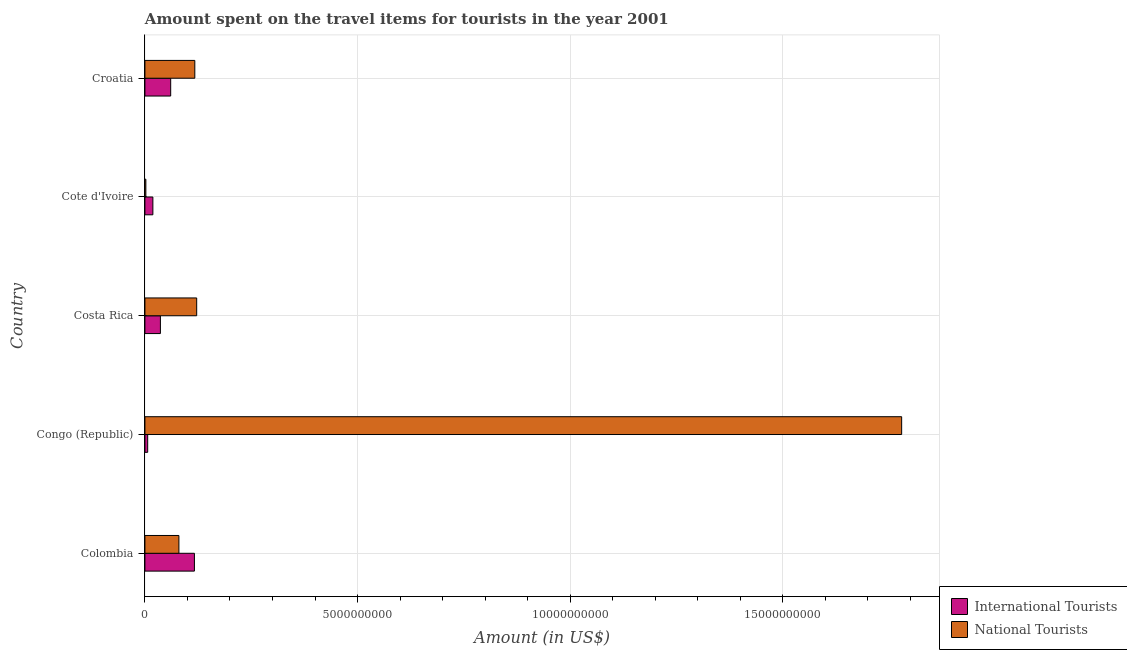How many different coloured bars are there?
Make the answer very short. 2. Are the number of bars per tick equal to the number of legend labels?
Keep it short and to the point. Yes. Are the number of bars on each tick of the Y-axis equal?
Your response must be concise. Yes. How many bars are there on the 1st tick from the top?
Offer a terse response. 2. What is the label of the 1st group of bars from the top?
Your answer should be compact. Croatia. What is the amount spent on travel items of international tourists in Costa Rica?
Your answer should be very brief. 3.64e+08. Across all countries, what is the maximum amount spent on travel items of national tourists?
Your answer should be compact. 1.78e+1. Across all countries, what is the minimum amount spent on travel items of international tourists?
Provide a short and direct response. 6.50e+07. In which country was the amount spent on travel items of international tourists maximum?
Make the answer very short. Colombia. In which country was the amount spent on travel items of national tourists minimum?
Offer a terse response. Cote d'Ivoire. What is the total amount spent on travel items of international tourists in the graph?
Provide a short and direct response. 2.39e+09. What is the difference between the amount spent on travel items of national tourists in Congo (Republic) and that in Croatia?
Your response must be concise. 1.66e+1. What is the difference between the amount spent on travel items of national tourists in Costa Rica and the amount spent on travel items of international tourists in Cote d'Ivoire?
Your answer should be very brief. 1.03e+09. What is the average amount spent on travel items of national tourists per country?
Your answer should be very brief. 4.20e+09. What is the difference between the amount spent on travel items of international tourists and amount spent on travel items of national tourists in Congo (Republic)?
Offer a very short reply. -1.77e+1. What is the ratio of the amount spent on travel items of international tourists in Colombia to that in Costa Rica?
Ensure brevity in your answer.  3.2. Is the amount spent on travel items of international tourists in Congo (Republic) less than that in Croatia?
Offer a very short reply. Yes. Is the difference between the amount spent on travel items of national tourists in Colombia and Croatia greater than the difference between the amount spent on travel items of international tourists in Colombia and Croatia?
Offer a very short reply. No. What is the difference between the highest and the second highest amount spent on travel items of international tourists?
Give a very brief answer. 5.58e+08. What is the difference between the highest and the lowest amount spent on travel items of international tourists?
Give a very brief answer. 1.10e+09. What does the 2nd bar from the top in Cote d'Ivoire represents?
Your answer should be very brief. International Tourists. What does the 1st bar from the bottom in Cote d'Ivoire represents?
Ensure brevity in your answer.  International Tourists. How many countries are there in the graph?
Make the answer very short. 5. Does the graph contain any zero values?
Your answer should be very brief. No. Where does the legend appear in the graph?
Keep it short and to the point. Bottom right. How many legend labels are there?
Provide a succinct answer. 2. What is the title of the graph?
Offer a terse response. Amount spent on the travel items for tourists in the year 2001. Does "Under-5(female)" appear as one of the legend labels in the graph?
Provide a succinct answer. No. What is the label or title of the Y-axis?
Give a very brief answer. Country. What is the Amount (in US$) of International Tourists in Colombia?
Your response must be concise. 1.16e+09. What is the Amount (in US$) in National Tourists in Colombia?
Your answer should be compact. 7.99e+08. What is the Amount (in US$) in International Tourists in Congo (Republic)?
Ensure brevity in your answer.  6.50e+07. What is the Amount (in US$) in National Tourists in Congo (Republic)?
Offer a very short reply. 1.78e+1. What is the Amount (in US$) of International Tourists in Costa Rica?
Your answer should be very brief. 3.64e+08. What is the Amount (in US$) in National Tourists in Costa Rica?
Your answer should be very brief. 1.22e+09. What is the Amount (in US$) of International Tourists in Cote d'Ivoire?
Your response must be concise. 1.87e+08. What is the Amount (in US$) in National Tourists in Cote d'Ivoire?
Provide a short and direct response. 2.20e+07. What is the Amount (in US$) of International Tourists in Croatia?
Offer a terse response. 6.06e+08. What is the Amount (in US$) of National Tourists in Croatia?
Offer a very short reply. 1.17e+09. Across all countries, what is the maximum Amount (in US$) of International Tourists?
Keep it short and to the point. 1.16e+09. Across all countries, what is the maximum Amount (in US$) in National Tourists?
Your answer should be compact. 1.78e+1. Across all countries, what is the minimum Amount (in US$) in International Tourists?
Offer a very short reply. 6.50e+07. Across all countries, what is the minimum Amount (in US$) in National Tourists?
Make the answer very short. 2.20e+07. What is the total Amount (in US$) in International Tourists in the graph?
Offer a terse response. 2.39e+09. What is the total Amount (in US$) in National Tourists in the graph?
Offer a terse response. 2.10e+1. What is the difference between the Amount (in US$) in International Tourists in Colombia and that in Congo (Republic)?
Offer a terse response. 1.10e+09. What is the difference between the Amount (in US$) of National Tourists in Colombia and that in Congo (Republic)?
Ensure brevity in your answer.  -1.70e+1. What is the difference between the Amount (in US$) in International Tourists in Colombia and that in Costa Rica?
Give a very brief answer. 8.00e+08. What is the difference between the Amount (in US$) of National Tourists in Colombia and that in Costa Rica?
Your answer should be very brief. -4.18e+08. What is the difference between the Amount (in US$) of International Tourists in Colombia and that in Cote d'Ivoire?
Make the answer very short. 9.77e+08. What is the difference between the Amount (in US$) of National Tourists in Colombia and that in Cote d'Ivoire?
Your response must be concise. 7.77e+08. What is the difference between the Amount (in US$) in International Tourists in Colombia and that in Croatia?
Keep it short and to the point. 5.58e+08. What is the difference between the Amount (in US$) in National Tourists in Colombia and that in Croatia?
Offer a very short reply. -3.74e+08. What is the difference between the Amount (in US$) in International Tourists in Congo (Republic) and that in Costa Rica?
Give a very brief answer. -2.99e+08. What is the difference between the Amount (in US$) in National Tourists in Congo (Republic) and that in Costa Rica?
Offer a terse response. 1.66e+1. What is the difference between the Amount (in US$) of International Tourists in Congo (Republic) and that in Cote d'Ivoire?
Offer a terse response. -1.22e+08. What is the difference between the Amount (in US$) of National Tourists in Congo (Republic) and that in Cote d'Ivoire?
Keep it short and to the point. 1.78e+1. What is the difference between the Amount (in US$) in International Tourists in Congo (Republic) and that in Croatia?
Provide a short and direct response. -5.41e+08. What is the difference between the Amount (in US$) in National Tourists in Congo (Republic) and that in Croatia?
Your answer should be compact. 1.66e+1. What is the difference between the Amount (in US$) of International Tourists in Costa Rica and that in Cote d'Ivoire?
Give a very brief answer. 1.77e+08. What is the difference between the Amount (in US$) of National Tourists in Costa Rica and that in Cote d'Ivoire?
Provide a succinct answer. 1.20e+09. What is the difference between the Amount (in US$) in International Tourists in Costa Rica and that in Croatia?
Offer a very short reply. -2.42e+08. What is the difference between the Amount (in US$) of National Tourists in Costa Rica and that in Croatia?
Your response must be concise. 4.40e+07. What is the difference between the Amount (in US$) of International Tourists in Cote d'Ivoire and that in Croatia?
Offer a terse response. -4.19e+08. What is the difference between the Amount (in US$) in National Tourists in Cote d'Ivoire and that in Croatia?
Keep it short and to the point. -1.15e+09. What is the difference between the Amount (in US$) in International Tourists in Colombia and the Amount (in US$) in National Tourists in Congo (Republic)?
Your answer should be very brief. -1.66e+1. What is the difference between the Amount (in US$) of International Tourists in Colombia and the Amount (in US$) of National Tourists in Costa Rica?
Your answer should be very brief. -5.30e+07. What is the difference between the Amount (in US$) of International Tourists in Colombia and the Amount (in US$) of National Tourists in Cote d'Ivoire?
Keep it short and to the point. 1.14e+09. What is the difference between the Amount (in US$) of International Tourists in Colombia and the Amount (in US$) of National Tourists in Croatia?
Offer a terse response. -9.00e+06. What is the difference between the Amount (in US$) in International Tourists in Congo (Republic) and the Amount (in US$) in National Tourists in Costa Rica?
Make the answer very short. -1.15e+09. What is the difference between the Amount (in US$) of International Tourists in Congo (Republic) and the Amount (in US$) of National Tourists in Cote d'Ivoire?
Offer a very short reply. 4.30e+07. What is the difference between the Amount (in US$) in International Tourists in Congo (Republic) and the Amount (in US$) in National Tourists in Croatia?
Offer a terse response. -1.11e+09. What is the difference between the Amount (in US$) in International Tourists in Costa Rica and the Amount (in US$) in National Tourists in Cote d'Ivoire?
Offer a terse response. 3.42e+08. What is the difference between the Amount (in US$) in International Tourists in Costa Rica and the Amount (in US$) in National Tourists in Croatia?
Offer a very short reply. -8.09e+08. What is the difference between the Amount (in US$) in International Tourists in Cote d'Ivoire and the Amount (in US$) in National Tourists in Croatia?
Offer a terse response. -9.86e+08. What is the average Amount (in US$) in International Tourists per country?
Your answer should be compact. 4.77e+08. What is the average Amount (in US$) of National Tourists per country?
Offer a terse response. 4.20e+09. What is the difference between the Amount (in US$) of International Tourists and Amount (in US$) of National Tourists in Colombia?
Offer a terse response. 3.65e+08. What is the difference between the Amount (in US$) of International Tourists and Amount (in US$) of National Tourists in Congo (Republic)?
Keep it short and to the point. -1.77e+1. What is the difference between the Amount (in US$) of International Tourists and Amount (in US$) of National Tourists in Costa Rica?
Offer a terse response. -8.53e+08. What is the difference between the Amount (in US$) in International Tourists and Amount (in US$) in National Tourists in Cote d'Ivoire?
Provide a short and direct response. 1.65e+08. What is the difference between the Amount (in US$) of International Tourists and Amount (in US$) of National Tourists in Croatia?
Ensure brevity in your answer.  -5.67e+08. What is the ratio of the Amount (in US$) in International Tourists in Colombia to that in Congo (Republic)?
Keep it short and to the point. 17.91. What is the ratio of the Amount (in US$) in National Tourists in Colombia to that in Congo (Republic)?
Offer a terse response. 0.04. What is the ratio of the Amount (in US$) in International Tourists in Colombia to that in Costa Rica?
Your response must be concise. 3.2. What is the ratio of the Amount (in US$) in National Tourists in Colombia to that in Costa Rica?
Offer a very short reply. 0.66. What is the ratio of the Amount (in US$) of International Tourists in Colombia to that in Cote d'Ivoire?
Keep it short and to the point. 6.22. What is the ratio of the Amount (in US$) of National Tourists in Colombia to that in Cote d'Ivoire?
Your response must be concise. 36.32. What is the ratio of the Amount (in US$) in International Tourists in Colombia to that in Croatia?
Your answer should be compact. 1.92. What is the ratio of the Amount (in US$) in National Tourists in Colombia to that in Croatia?
Give a very brief answer. 0.68. What is the ratio of the Amount (in US$) in International Tourists in Congo (Republic) to that in Costa Rica?
Keep it short and to the point. 0.18. What is the ratio of the Amount (in US$) of National Tourists in Congo (Republic) to that in Costa Rica?
Provide a short and direct response. 14.62. What is the ratio of the Amount (in US$) in International Tourists in Congo (Republic) to that in Cote d'Ivoire?
Keep it short and to the point. 0.35. What is the ratio of the Amount (in US$) of National Tourists in Congo (Republic) to that in Cote d'Ivoire?
Make the answer very short. 808.73. What is the ratio of the Amount (in US$) of International Tourists in Congo (Republic) to that in Croatia?
Keep it short and to the point. 0.11. What is the ratio of the Amount (in US$) of National Tourists in Congo (Republic) to that in Croatia?
Provide a short and direct response. 15.17. What is the ratio of the Amount (in US$) in International Tourists in Costa Rica to that in Cote d'Ivoire?
Give a very brief answer. 1.95. What is the ratio of the Amount (in US$) in National Tourists in Costa Rica to that in Cote d'Ivoire?
Provide a short and direct response. 55.32. What is the ratio of the Amount (in US$) of International Tourists in Costa Rica to that in Croatia?
Offer a terse response. 0.6. What is the ratio of the Amount (in US$) in National Tourists in Costa Rica to that in Croatia?
Keep it short and to the point. 1.04. What is the ratio of the Amount (in US$) of International Tourists in Cote d'Ivoire to that in Croatia?
Provide a short and direct response. 0.31. What is the ratio of the Amount (in US$) in National Tourists in Cote d'Ivoire to that in Croatia?
Make the answer very short. 0.02. What is the difference between the highest and the second highest Amount (in US$) in International Tourists?
Keep it short and to the point. 5.58e+08. What is the difference between the highest and the second highest Amount (in US$) in National Tourists?
Offer a terse response. 1.66e+1. What is the difference between the highest and the lowest Amount (in US$) in International Tourists?
Offer a very short reply. 1.10e+09. What is the difference between the highest and the lowest Amount (in US$) of National Tourists?
Your response must be concise. 1.78e+1. 